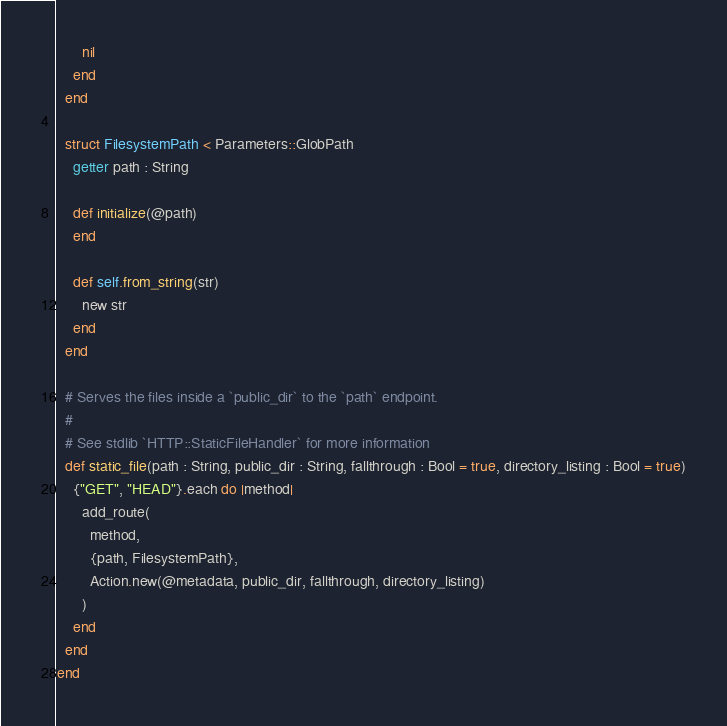<code> <loc_0><loc_0><loc_500><loc_500><_Crystal_>
      nil
    end
  end

  struct FilesystemPath < Parameters::GlobPath
    getter path : String

    def initialize(@path)
    end

    def self.from_string(str)
      new str
    end
  end

  # Serves the files inside a `public_dir` to the `path` endpoint.
  #
  # See stdlib `HTTP::StaticFileHandler` for more information
  def static_file(path : String, public_dir : String, fallthrough : Bool = true, directory_listing : Bool = true)
    {"GET", "HEAD"}.each do |method|
      add_route(
        method,
        {path, FilesystemPath},
        Action.new(@metadata, public_dir, fallthrough, directory_listing)
      )
    end
  end
end
</code> 